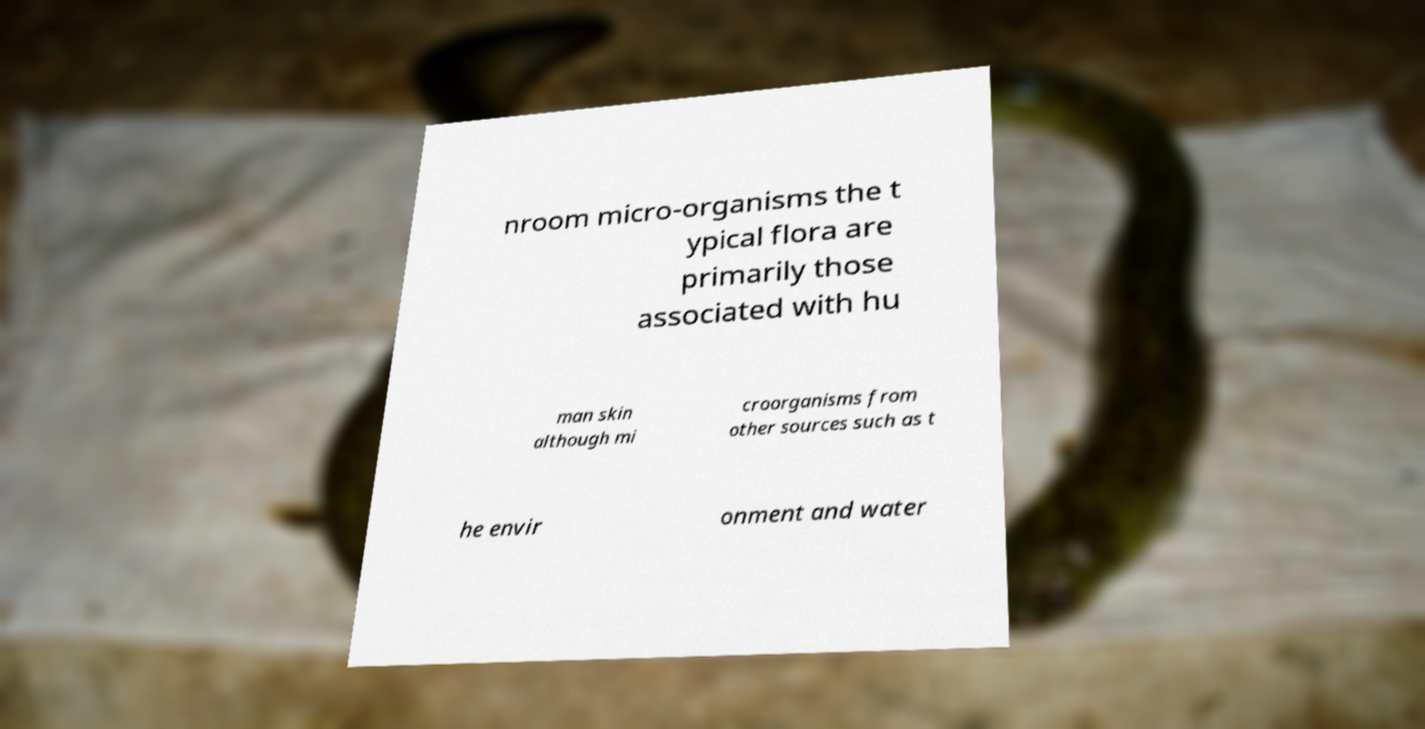Please read and relay the text visible in this image. What does it say? nroom micro-organisms the t ypical flora are primarily those associated with hu man skin although mi croorganisms from other sources such as t he envir onment and water 